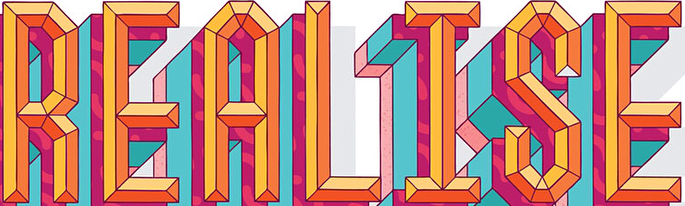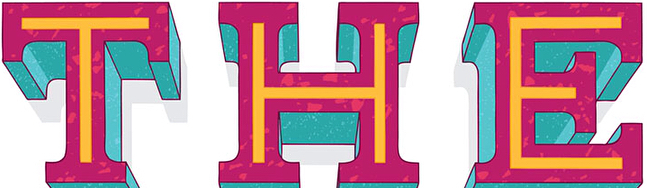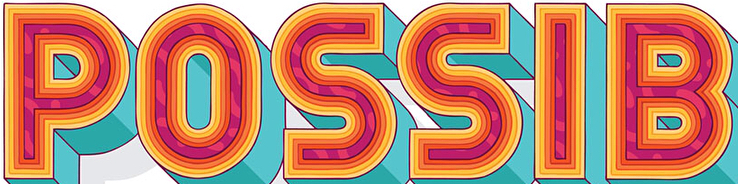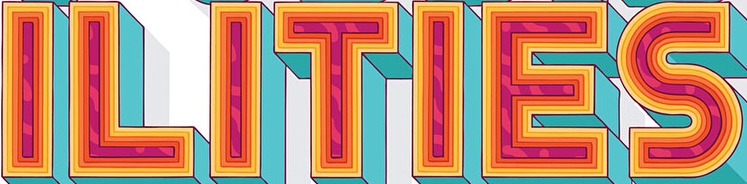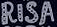What text is displayed in these images sequentially, separated by a semicolon? REALISE; THE; POSSIB; ILITIES; RISA 